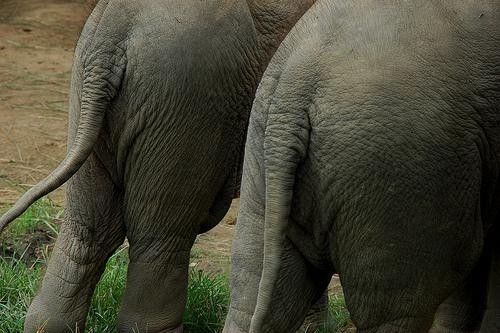Question: how many elephants are there?
Choices:
A. 1.
B. 2.
C. 3.
D. 4.
Answer with the letter. Answer: B Question: what is the color of their skin?
Choices:
A. Gray.
B. Brown.
C. Blue.
D. Yellow.
Answer with the letter. Answer: A Question: who is with them?
Choices:
A. 2 people.
B. A friend.
C. No one.
D. Mother.
Answer with the letter. Answer: C 